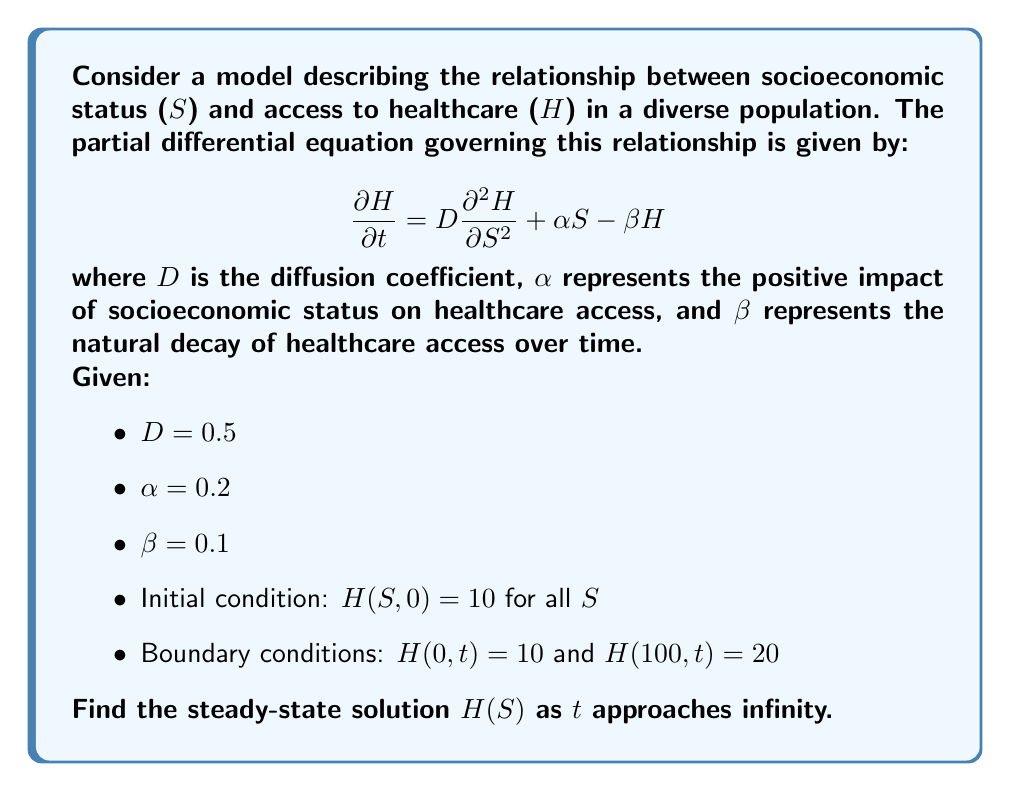Provide a solution to this math problem. To find the steady-state solution, we follow these steps:

1) In steady-state, the time derivative becomes zero:
   $$\frac{\partial H}{\partial t} = 0$$

2) Substituting this into the original PDE:
   $$0 = D\frac{\partial^2 H}{\partial S^2} + \alpha S - \beta H$$

3) Rearranging the equation:
   $$D\frac{\partial^2 H}{\partial S^2} - \beta H = -\alpha S$$

4) This is a non-homogeneous second-order ODE. The general solution has the form:
   $$H(S) = H_h(S) + H_p(S)$$
   where $H_h(S)$ is the homogeneous solution and $H_p(S)$ is a particular solution.

5) For the homogeneous part, we solve:
   $$D\frac{d^2 H_h}{dS^2} - \beta H_h = 0$$
   The characteristic equation is $Dr^2 - \beta = 0$, giving:
   $$r = \pm \sqrt{\frac{\beta}{D}} = \pm \sqrt{\frac{0.1}{0.5}} = \pm \frac{1}{\sqrt{5}}$$
   So, $H_h(S) = c_1e^{S/\sqrt{5}} + c_2e^{-S/\sqrt{5}}$

6) For the particular solution, we guess the form $H_p(S) = AS + B$. Substituting this into the original ODE:
   $$0 - \beta(AS + B) = -\alpha S$$
   $$-\beta AS - \beta B = -\alpha S$$
   Equating coefficients:
   $$A = \frac{\alpha}{\beta} = \frac{0.2}{0.1} = 2$$
   $$B = 0$$

7) The general solution is thus:
   $$H(S) = c_1e^{S/\sqrt{5}} + c_2e^{-S/\sqrt{5}} + 2S$$

8) Using the boundary conditions:
   At S = 0: $10 = c_1 + c_2$
   At S = 100: $20 = c_1e^{100/\sqrt{5}} + c_2e^{-100/\sqrt{5}} + 200$

9) Solving this system of equations:
   $c_1 \approx 5.0000$ and $c_2 \approx 4.9999$

Therefore, the steady-state solution is:
$$H(S) \approx 5.0000e^{S/\sqrt{5}} + 4.9999e^{-S/\sqrt{5}} + 2S$$
Answer: $H(S) \approx 5.0000e^{S/\sqrt{5}} + 4.9999e^{-S/\sqrt{5}} + 2S$ 